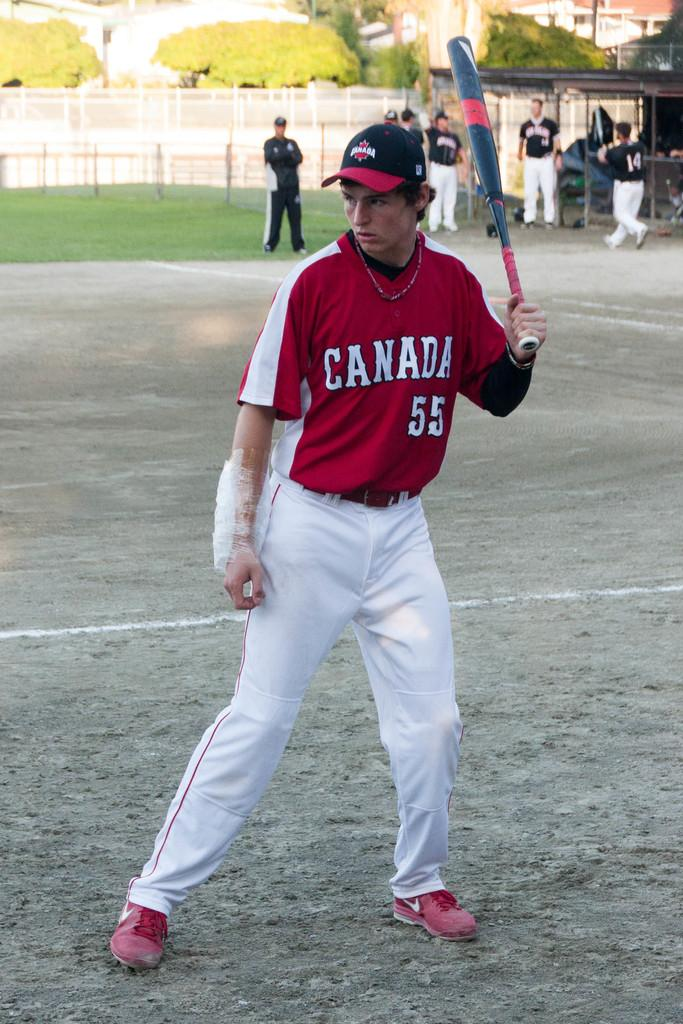<image>
Write a terse but informative summary of the picture. Player 55 of the Canada baseball team has a large bandage on his arm. 